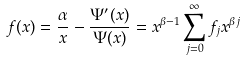<formula> <loc_0><loc_0><loc_500><loc_500>f ( x ) = \frac { \alpha } { x } - \frac { \Psi ^ { \prime } ( x ) } { \Psi ( x ) } = x ^ { \beta - 1 } \sum _ { j = 0 } ^ { \infty } f _ { j } x ^ { \beta j }</formula> 